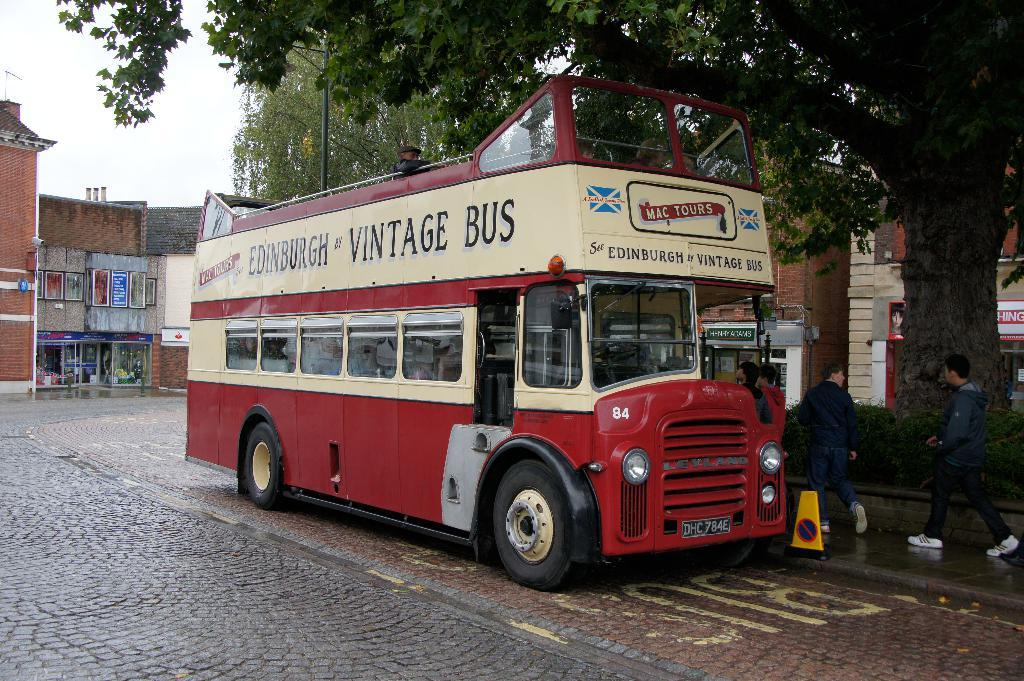Provide a one-sentence caption for the provided image. a bus that has vintage bus written on it. 